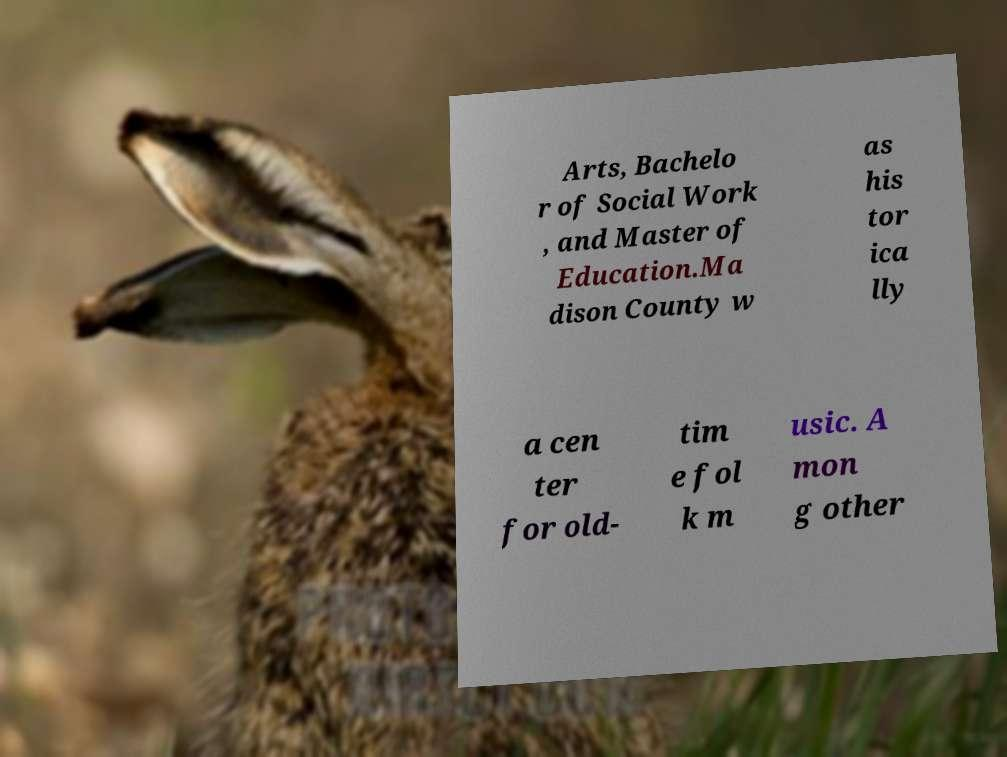Could you assist in decoding the text presented in this image and type it out clearly? Arts, Bachelo r of Social Work , and Master of Education.Ma dison County w as his tor ica lly a cen ter for old- tim e fol k m usic. A mon g other 